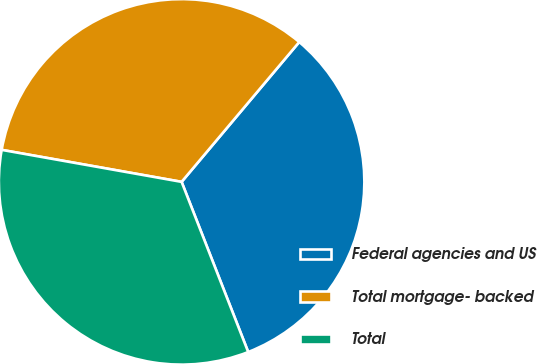<chart> <loc_0><loc_0><loc_500><loc_500><pie_chart><fcel>Federal agencies and US<fcel>Total mortgage- backed<fcel>Total<nl><fcel>32.93%<fcel>33.33%<fcel>33.74%<nl></chart> 